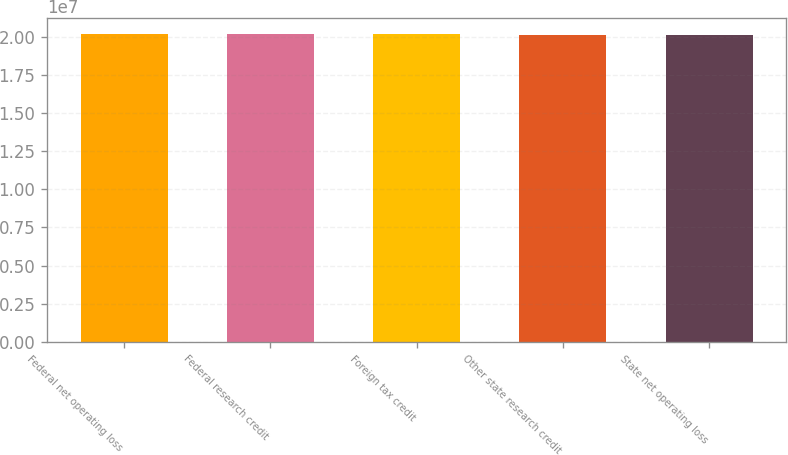<chart> <loc_0><loc_0><loc_500><loc_500><bar_chart><fcel>Federal net operating loss<fcel>Federal research credit<fcel>Foreign tax credit<fcel>Other state research credit<fcel>State net operating loss<nl><fcel>2.0182e+07<fcel>2.0172e+07<fcel>2.0152e+07<fcel>2.0137e+07<fcel>2.0132e+07<nl></chart> 